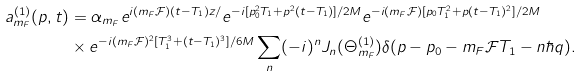<formula> <loc_0><loc_0><loc_500><loc_500>a _ { m _ { F } } ^ { ( 1 ) } ( p , t ) & = \alpha _ { m _ { F } } e ^ { i ( m _ { F } \mathcal { F } ) ( t - T _ { 1 } ) z / } e ^ { - i [ p _ { 0 } ^ { 2 } T _ { 1 } + p ^ { 2 } ( t - T _ { 1 } ) ] / 2 M } e ^ { - i ( m _ { F } \mathcal { F } ) [ p _ { 0 } T _ { 1 } ^ { 2 } + p ( t - T _ { 1 } ) ^ { 2 } ] / 2 M } \\ & \times e ^ { - i ( m _ { F } \mathcal { F } ) ^ { 2 } [ T _ { 1 } ^ { 3 } + ( t - T _ { 1 } ) ^ { 3 } ] / 6 M } \sum _ { n } ( - i ) ^ { n } J _ { n } ( \Theta _ { m _ { F } } ^ { ( 1 ) } ) \delta ( p - p _ { 0 } - m _ { F } \mathcal { F } T _ { 1 } - n \hbar { q } ) .</formula> 